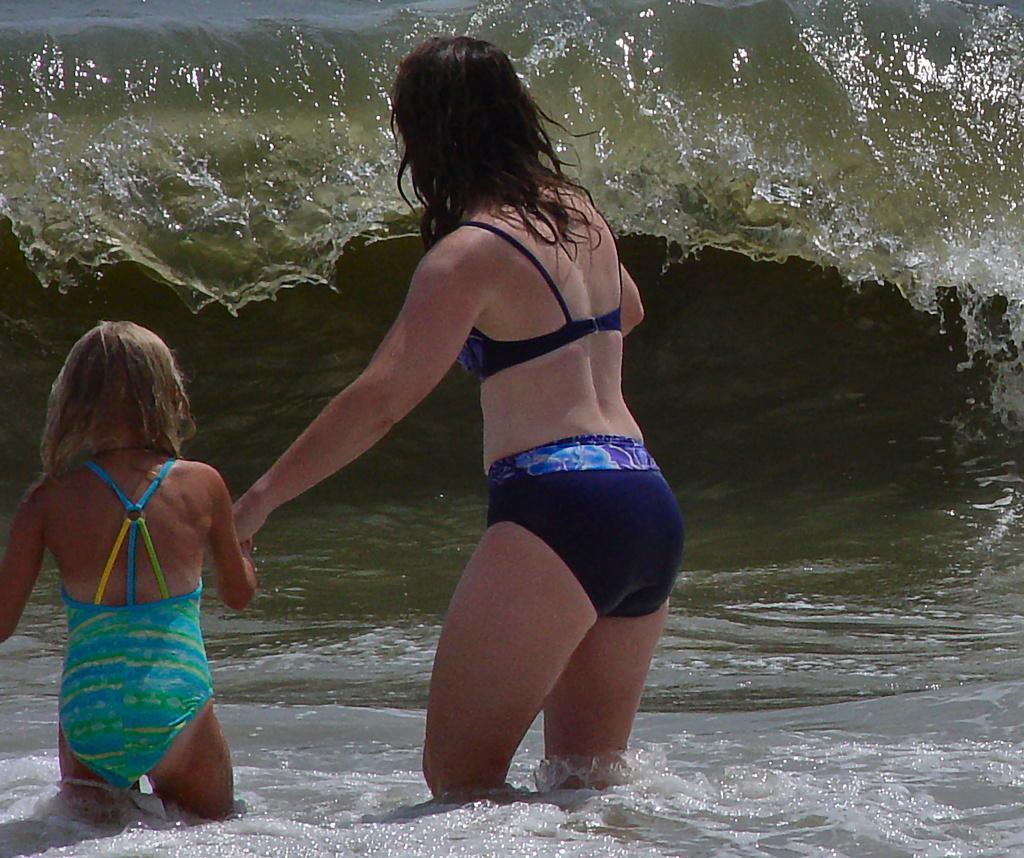Could you give a brief overview of what you see in this image? In this image I can see in the middle a woman is going into the sea by holding the girl with her hand. 